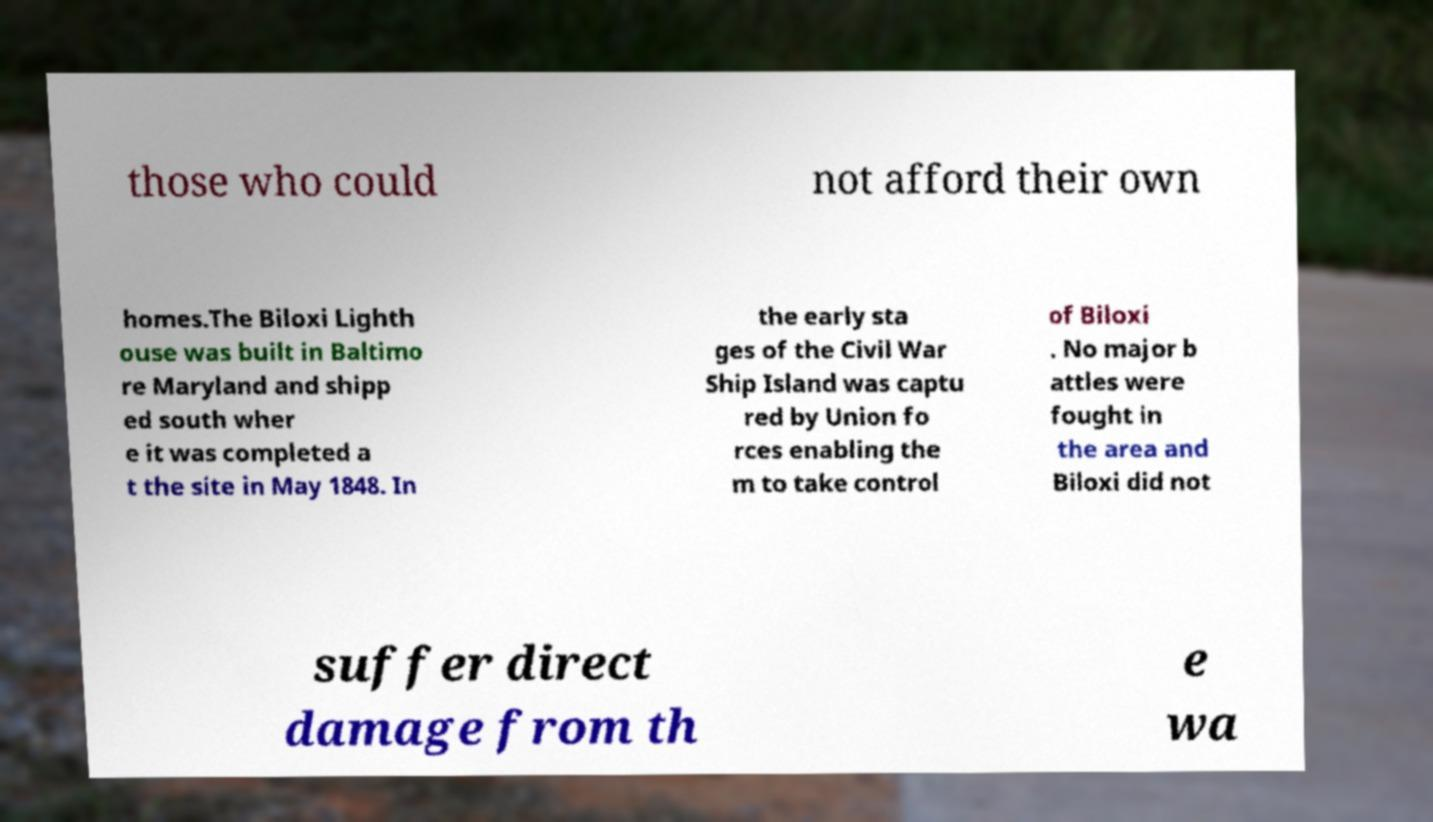For documentation purposes, I need the text within this image transcribed. Could you provide that? those who could not afford their own homes.The Biloxi Lighth ouse was built in Baltimo re Maryland and shipp ed south wher e it was completed a t the site in May 1848. In the early sta ges of the Civil War Ship Island was captu red by Union fo rces enabling the m to take control of Biloxi . No major b attles were fought in the area and Biloxi did not suffer direct damage from th e wa 